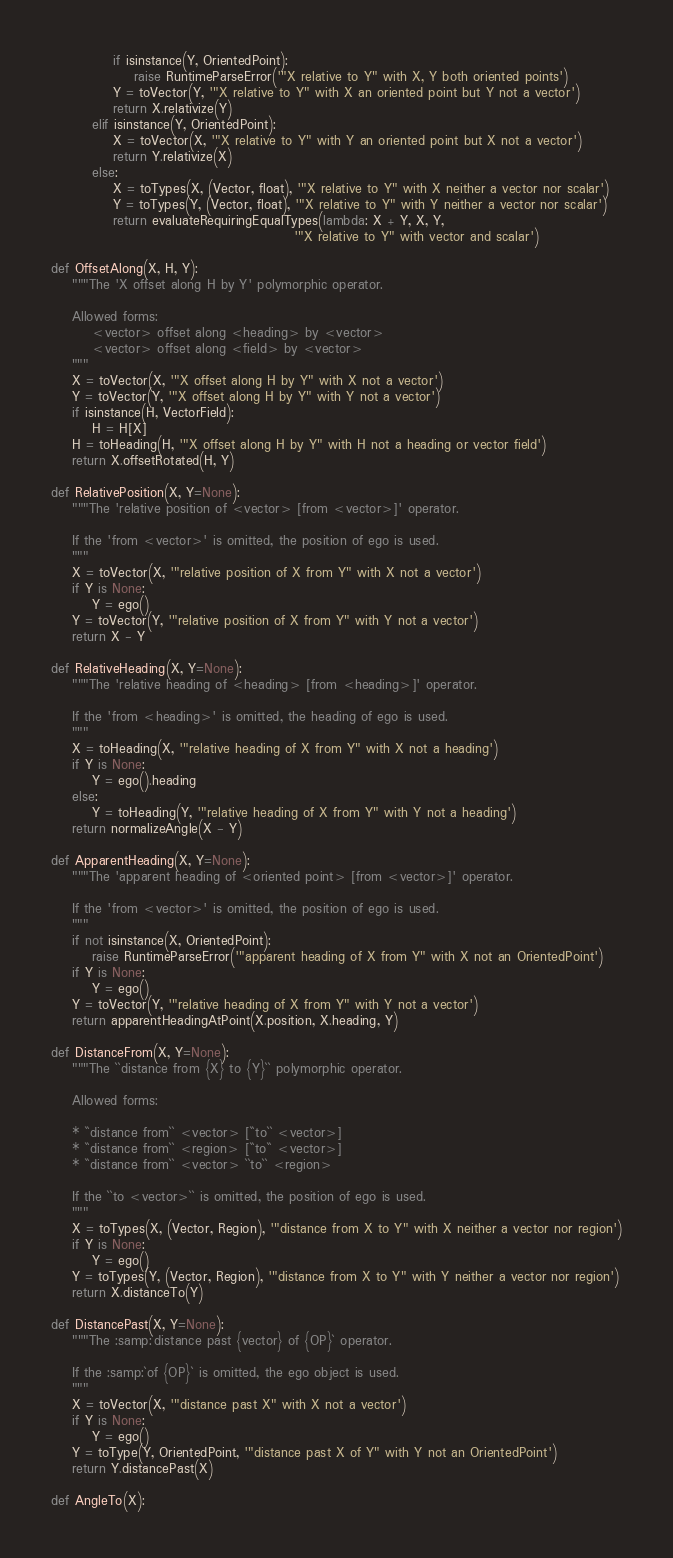<code> <loc_0><loc_0><loc_500><loc_500><_Python_>			if isinstance(Y, OrientedPoint):
				raise RuntimeParseError('"X relative to Y" with X, Y both oriented points')
			Y = toVector(Y, '"X relative to Y" with X an oriented point but Y not a vector')
			return X.relativize(Y)
		elif isinstance(Y, OrientedPoint):
			X = toVector(X, '"X relative to Y" with Y an oriented point but X not a vector')
			return Y.relativize(X)
		else:
			X = toTypes(X, (Vector, float), '"X relative to Y" with X neither a vector nor scalar')
			Y = toTypes(Y, (Vector, float), '"X relative to Y" with Y neither a vector nor scalar')
			return evaluateRequiringEqualTypes(lambda: X + Y, X, Y,
											   '"X relative to Y" with vector and scalar')

def OffsetAlong(X, H, Y):
	"""The 'X offset along H by Y' polymorphic operator.

	Allowed forms:
		<vector> offset along <heading> by <vector>
		<vector> offset along <field> by <vector>
	"""
	X = toVector(X, '"X offset along H by Y" with X not a vector')
	Y = toVector(Y, '"X offset along H by Y" with Y not a vector')
	if isinstance(H, VectorField):
		H = H[X]
	H = toHeading(H, '"X offset along H by Y" with H not a heading or vector field')
	return X.offsetRotated(H, Y)

def RelativePosition(X, Y=None):
	"""The 'relative position of <vector> [from <vector>]' operator.

	If the 'from <vector>' is omitted, the position of ego is used.
	"""
	X = toVector(X, '"relative position of X from Y" with X not a vector')
	if Y is None:
		Y = ego()
	Y = toVector(Y, '"relative position of X from Y" with Y not a vector')
	return X - Y

def RelativeHeading(X, Y=None):
	"""The 'relative heading of <heading> [from <heading>]' operator.

	If the 'from <heading>' is omitted, the heading of ego is used.
	"""
	X = toHeading(X, '"relative heading of X from Y" with X not a heading')
	if Y is None:
		Y = ego().heading
	else:
		Y = toHeading(Y, '"relative heading of X from Y" with Y not a heading')
	return normalizeAngle(X - Y)

def ApparentHeading(X, Y=None):
	"""The 'apparent heading of <oriented point> [from <vector>]' operator.

	If the 'from <vector>' is omitted, the position of ego is used.
	"""
	if not isinstance(X, OrientedPoint):
		raise RuntimeParseError('"apparent heading of X from Y" with X not an OrientedPoint')
	if Y is None:
		Y = ego()
	Y = toVector(Y, '"relative heading of X from Y" with Y not a vector')
	return apparentHeadingAtPoint(X.position, X.heading, Y)

def DistanceFrom(X, Y=None):
	"""The ``distance from {X} to {Y}`` polymorphic operator.

	Allowed forms:

	* ``distance from`` <vector> [``to`` <vector>]
	* ``distance from`` <region> [``to`` <vector>]
	* ``distance from`` <vector> ``to`` <region>

	If the ``to <vector>`` is omitted, the position of ego is used.
	"""
	X = toTypes(X, (Vector, Region), '"distance from X to Y" with X neither a vector nor region')
	if Y is None:
		Y = ego()
	Y = toTypes(Y, (Vector, Region), '"distance from X to Y" with Y neither a vector nor region')
	return X.distanceTo(Y)

def DistancePast(X, Y=None):
	"""The :samp:`distance past {vector} of {OP}` operator.

	If the :samp:`of {OP}` is omitted, the ego object is used.
	"""
	X = toVector(X, '"distance past X" with X not a vector')
	if Y is None:
		Y = ego()
	Y = toType(Y, OrientedPoint, '"distance past X of Y" with Y not an OrientedPoint')
	return Y.distancePast(X)

def AngleTo(X):</code> 